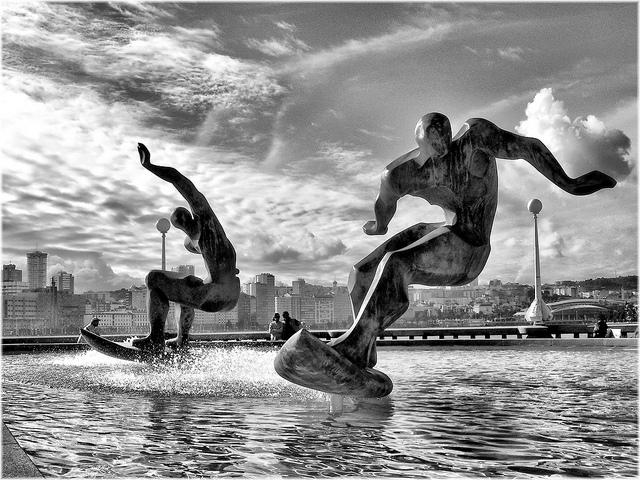What energy powers the splash? Please explain your reasoning. electricity. To create the splashing in this picture electricity must be used to achieve the effect. 